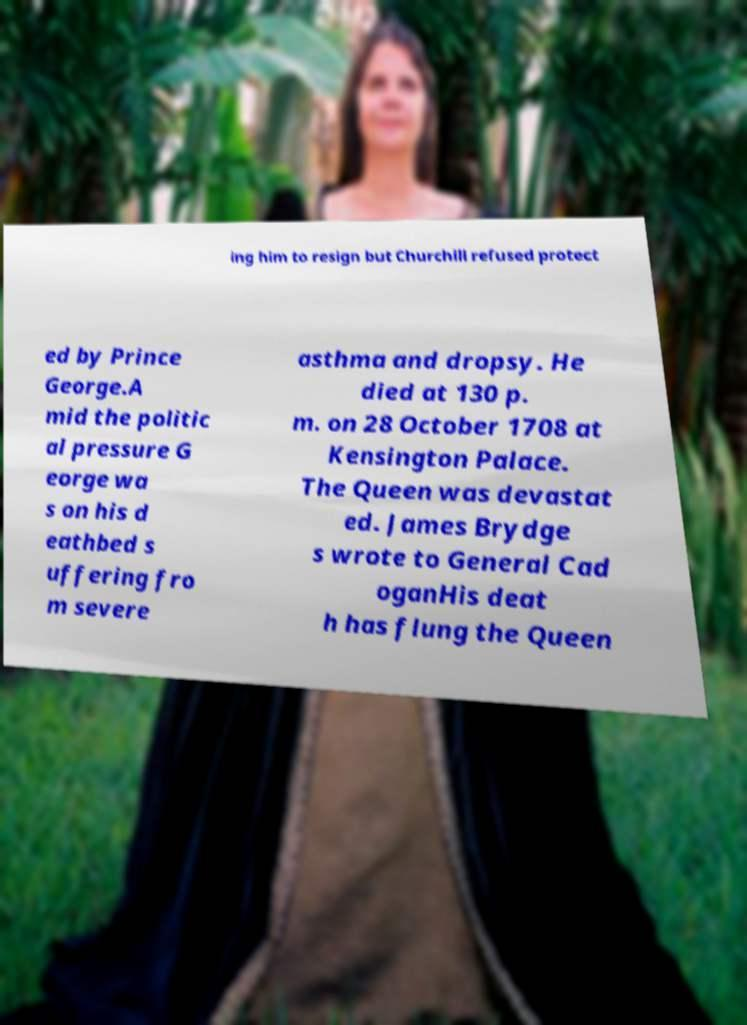For documentation purposes, I need the text within this image transcribed. Could you provide that? ing him to resign but Churchill refused protect ed by Prince George.A mid the politic al pressure G eorge wa s on his d eathbed s uffering fro m severe asthma and dropsy. He died at 130 p. m. on 28 October 1708 at Kensington Palace. The Queen was devastat ed. James Brydge s wrote to General Cad oganHis deat h has flung the Queen 